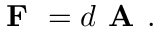Convert formula to latex. <formula><loc_0><loc_0><loc_500><loc_500>{ F } = d { A } .</formula> 